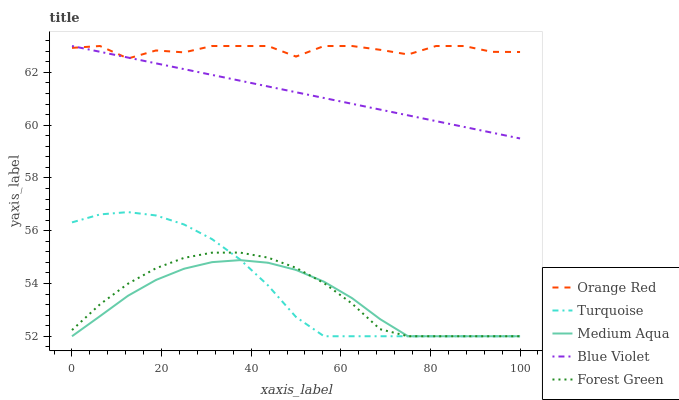Does Medium Aqua have the minimum area under the curve?
Answer yes or no. Yes. Does Orange Red have the maximum area under the curve?
Answer yes or no. Yes. Does Turquoise have the minimum area under the curve?
Answer yes or no. No. Does Turquoise have the maximum area under the curve?
Answer yes or no. No. Is Blue Violet the smoothest?
Answer yes or no. Yes. Is Orange Red the roughest?
Answer yes or no. Yes. Is Turquoise the smoothest?
Answer yes or no. No. Is Turquoise the roughest?
Answer yes or no. No. Does Forest Green have the lowest value?
Answer yes or no. Yes. Does Orange Red have the lowest value?
Answer yes or no. No. Does Blue Violet have the highest value?
Answer yes or no. Yes. Does Turquoise have the highest value?
Answer yes or no. No. Is Forest Green less than Blue Violet?
Answer yes or no. Yes. Is Blue Violet greater than Turquoise?
Answer yes or no. Yes. Does Turquoise intersect Medium Aqua?
Answer yes or no. Yes. Is Turquoise less than Medium Aqua?
Answer yes or no. No. Is Turquoise greater than Medium Aqua?
Answer yes or no. No. Does Forest Green intersect Blue Violet?
Answer yes or no. No. 